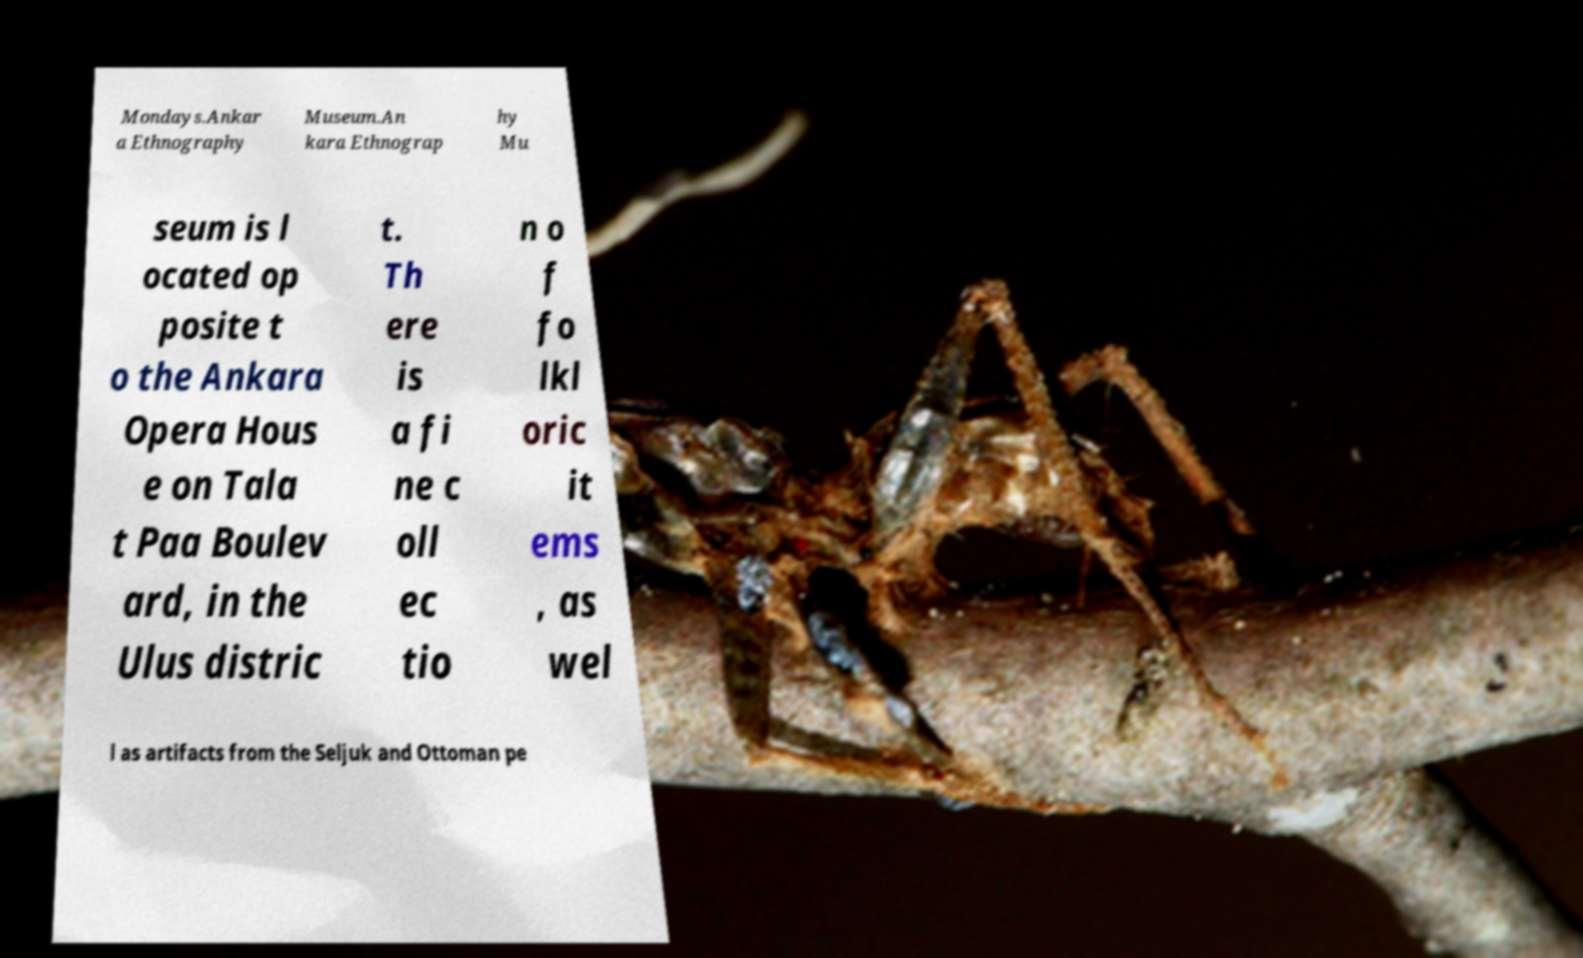I need the written content from this picture converted into text. Can you do that? Mondays.Ankar a Ethnography Museum.An kara Ethnograp hy Mu seum is l ocated op posite t o the Ankara Opera Hous e on Tala t Paa Boulev ard, in the Ulus distric t. Th ere is a fi ne c oll ec tio n o f fo lkl oric it ems , as wel l as artifacts from the Seljuk and Ottoman pe 